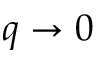<formula> <loc_0><loc_0><loc_500><loc_500>q \to 0</formula> 